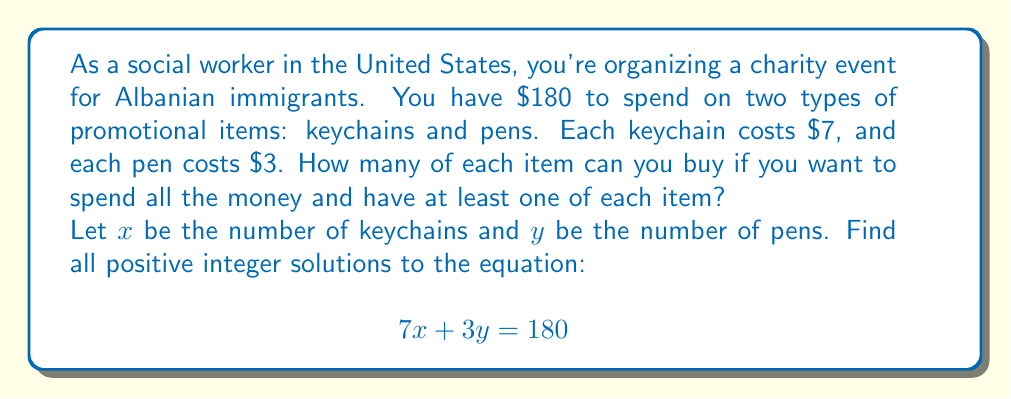Can you solve this math problem? To solve this linear Diophantine equation, we'll follow these steps:

1) First, we need to check if a solution exists. The GCD of the coefficients (7 and 3) should divide the constant term (180):
   
   $GCD(7,3) = 1$, which divides 180, so solutions exist.

2) We can rewrite the equation as:
   
   $$7x + 3y = 180$$
   $$7x = 180 - 3y$$
   $$x = \frac{180 - 3y}{7}$$

3) For $x$ to be an integer, $(180 - 3y)$ must be divisible by 7. Let's set up a congruence:
   
   $$180 - 3y \equiv 0 \pmod{7}$$
   $$-3y \equiv -180 \equiv 4 \pmod{7}$$
   $$y \equiv 4 \cdot 5 \equiv 6 \pmod{7}$$

4) The general solution for $y$ is:
   
   $$y = 7k + 6$$, where $k$ is a non-negative integer.

5) Substituting this back into the equation for $x$:
   
   $$x = \frac{180 - 3(7k + 6)}{7} = \frac{180 - 21k - 18}{7} = 23 - 3k$$

6) For positive integer solutions, we need:
   
   $$y = 7k + 6 > 0$$ (always true for non-negative $k$)
   $$x = 23 - 3k > 0$$
   $$23 > 3k$$
   $$7 > k$$

7) Therefore, $k$ can be 0, 1, 2, 3, 4, 5, or 6.

8) The solutions are:
   For $k = 0$: $x = 23$, $y = 6$
   For $k = 1$: $x = 20$, $y = 13$
   For $k = 2$: $x = 17$, $y = 20$
   For $k = 3$: $x = 14$, $y = 27$
   For $k = 4$: $x = 11$, $y = 34$
   For $k = 5$: $x = 8$,  $y = 41$
   For $k = 6$: $x = 5$,  $y = 48$
Answer: (23,6), (20,13), (17,20), (14,27), (11,34), (8,41), (5,48) 